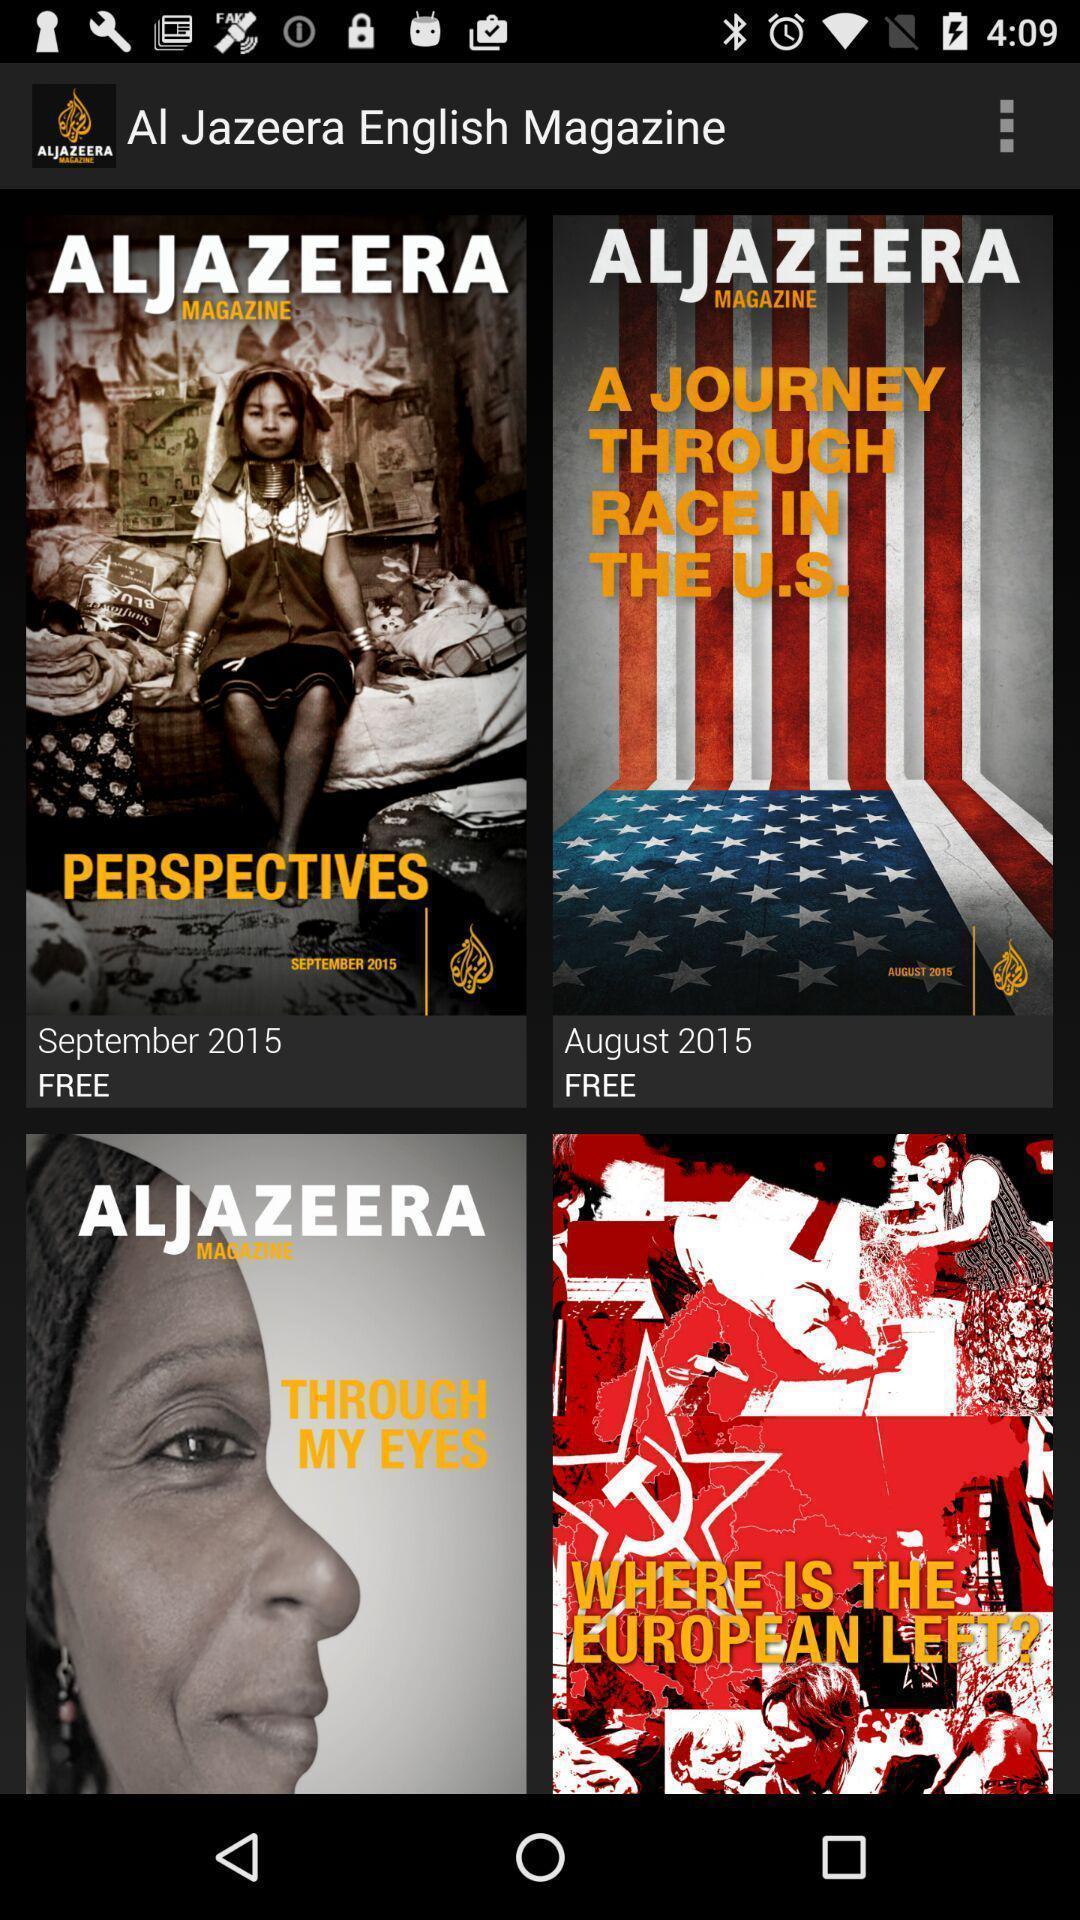Describe the visual elements of this screenshot. Page displaying the different magazines. 